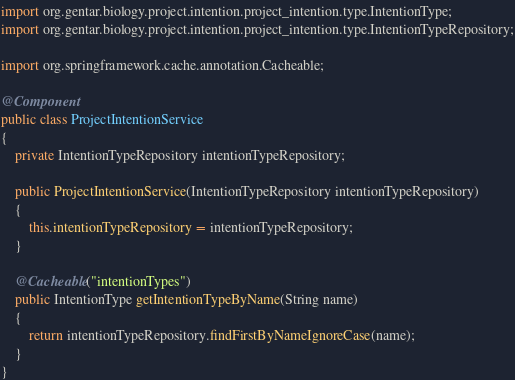<code> <loc_0><loc_0><loc_500><loc_500><_Java_>import org.gentar.biology.project.intention.project_intention.type.IntentionType;
import org.gentar.biology.project.intention.project_intention.type.IntentionTypeRepository;

import org.springframework.cache.annotation.Cacheable;

@Component
public class ProjectIntentionService
{
    private IntentionTypeRepository intentionTypeRepository;

    public ProjectIntentionService(IntentionTypeRepository intentionTypeRepository)
    {
        this.intentionTypeRepository = intentionTypeRepository;
    }

    @Cacheable("intentionTypes")
    public IntentionType getIntentionTypeByName(String name)
    {
        return intentionTypeRepository.findFirstByNameIgnoreCase(name);
    }
}
</code> 